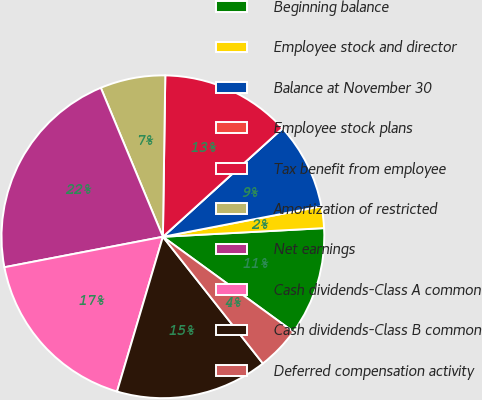<chart> <loc_0><loc_0><loc_500><loc_500><pie_chart><fcel>Beginning balance<fcel>Employee stock and director<fcel>Balance at November 30<fcel>Employee stock plans<fcel>Tax benefit from employee<fcel>Amortization of restricted<fcel>Net earnings<fcel>Cash dividends-Class A common<fcel>Cash dividends-Class B common<fcel>Deferred compensation activity<nl><fcel>10.87%<fcel>2.17%<fcel>8.7%<fcel>0.0%<fcel>13.04%<fcel>6.52%<fcel>21.74%<fcel>17.39%<fcel>15.22%<fcel>4.35%<nl></chart> 